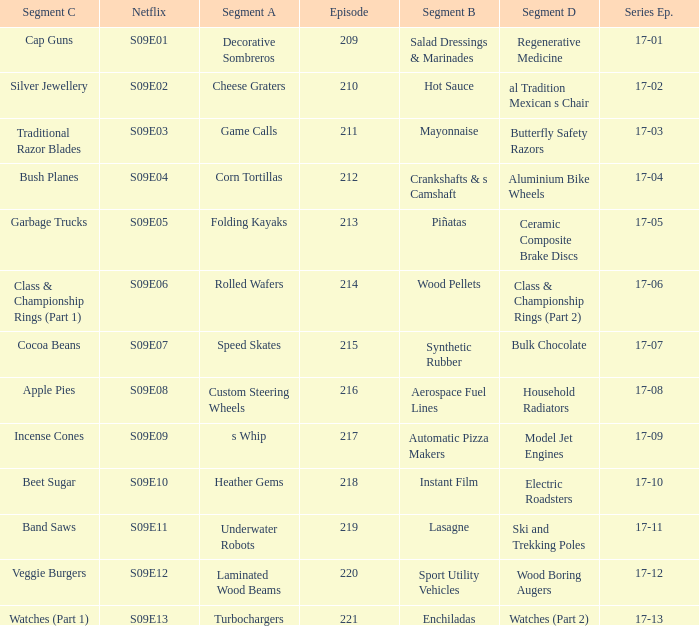Segment A of heather gems is what netflix episode? S09E10. 